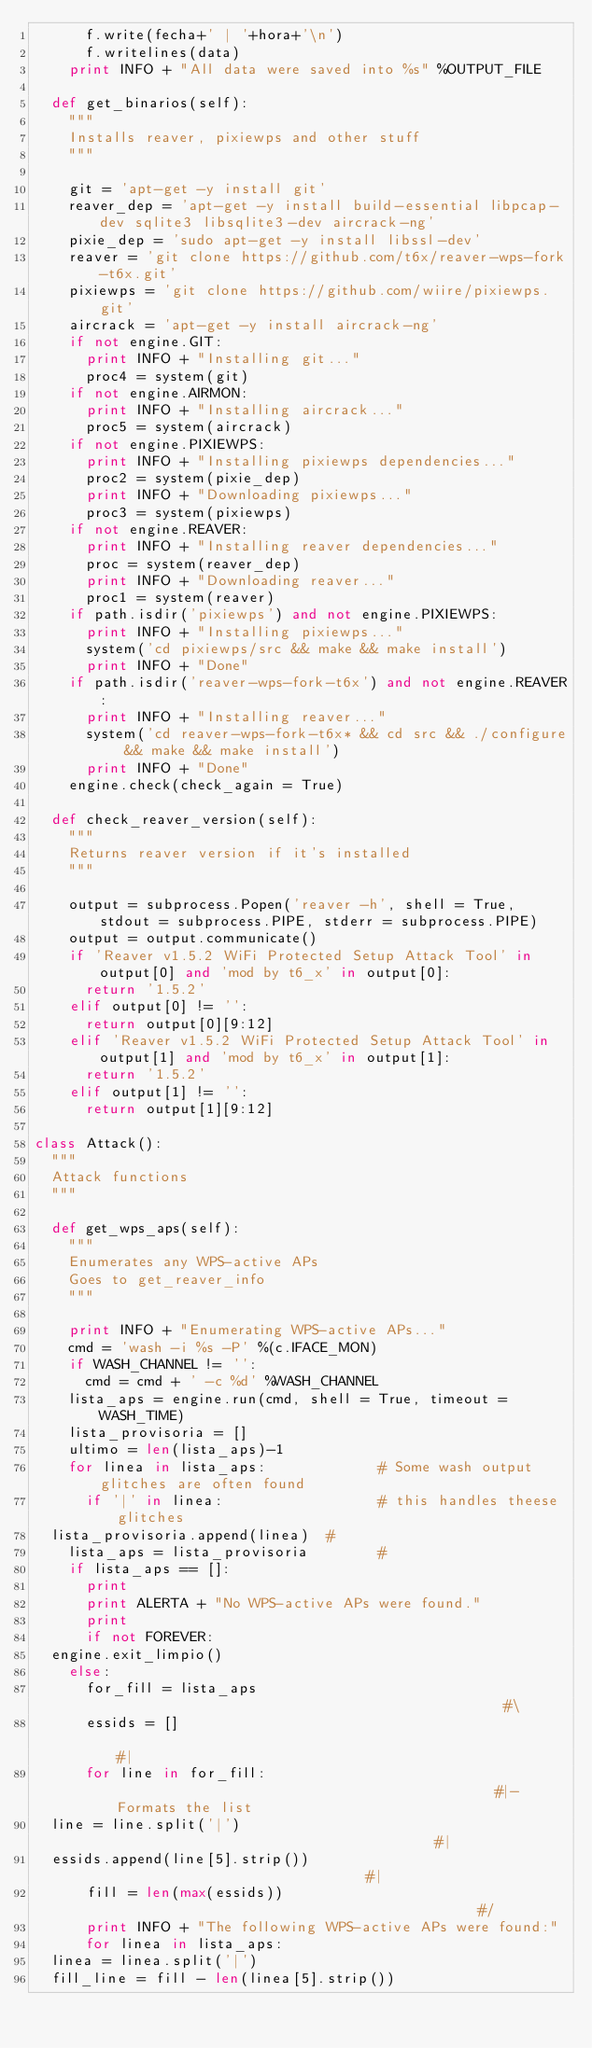Convert code to text. <code><loc_0><loc_0><loc_500><loc_500><_Python_>      f.write(fecha+' | '+hora+'\n')
      f.writelines(data)
    print INFO + "All data were saved into %s" %OUTPUT_FILE
    
  def get_binarios(self):
    """
    Installs reaver, pixiewps and other stuff
    """
    
    git = 'apt-get -y install git'
    reaver_dep = 'apt-get -y install build-essential libpcap-dev sqlite3 libsqlite3-dev aircrack-ng'
    pixie_dep = 'sudo apt-get -y install libssl-dev'
    reaver = 'git clone https://github.com/t6x/reaver-wps-fork-t6x.git'
    pixiewps = 'git clone https://github.com/wiire/pixiewps.git'
    aircrack = 'apt-get -y install aircrack-ng'
    if not engine.GIT:
      print INFO + "Installing git..."
      proc4 = system(git)
    if not engine.AIRMON:
      print INFO + "Installing aircrack..."
      proc5 = system(aircrack)
    if not engine.PIXIEWPS:
      print INFO + "Installing pixiewps dependencies..."
      proc2 = system(pixie_dep)
      print INFO + "Downloading pixiewps..."
      proc3 = system(pixiewps)    
    if not engine.REAVER:
      print INFO + "Installing reaver dependencies..."
      proc = system(reaver_dep)
      print INFO + "Downloading reaver..."
      proc1 = system(reaver)
    if path.isdir('pixiewps') and not engine.PIXIEWPS:
      print INFO + "Installing pixiewps..."
      system('cd pixiewps/src && make && make install')
      print INFO + "Done"
    if path.isdir('reaver-wps-fork-t6x') and not engine.REAVER:
      print INFO + "Installing reaver..."
      system('cd reaver-wps-fork-t6x* && cd src && ./configure && make && make install')
      print INFO + "Done"
    engine.check(check_again = True)

  def check_reaver_version(self):
    """
    Returns reaver version if it's installed
    """
    
    output = subprocess.Popen('reaver -h', shell = True, stdout = subprocess.PIPE, stderr = subprocess.PIPE)
    output = output.communicate()
    if 'Reaver v1.5.2 WiFi Protected Setup Attack Tool' in output[0] and 'mod by t6_x' in output[0]:
      return '1.5.2'
    elif output[0] != '':
      return output[0][9:12]
    elif 'Reaver v1.5.2 WiFi Protected Setup Attack Tool' in output[1] and 'mod by t6_x' in output[1]:
      return '1.5.2'
    elif output[1] != '':
      return output[1][9:12]

class Attack():
  """
  Attack functions
  """
  
  def get_wps_aps(self):
    """
    Enumerates any WPS-active APs
    Goes to get_reaver_info
    """

    print INFO + "Enumerating WPS-active APs..."
    cmd = 'wash -i %s -P' %(c.IFACE_MON)
    if WASH_CHANNEL != '':
      cmd = cmd + ' -c %d' %WASH_CHANNEL
    lista_aps = engine.run(cmd, shell = True, timeout = WASH_TIME)
    lista_provisoria = []
    ultimo = len(lista_aps)-1
    for linea in lista_aps:             # Some wash output glitches are often found
      if '|' in linea:                  # this handles theese glitches
	lista_provisoria.append(linea)  #
    lista_aps = lista_provisoria        #
    if lista_aps == []:
      print
      print ALERTA + "No WPS-active APs were found."
      print
      if not FOREVER:
	engine.exit_limpio()
    else:
      for_fill = lista_aps                                              #\
      essids = []                                                       #|
      for line in for_fill:                                             #|- Formats the list
	line = line.split('|')                                          #|
	essids.append(line[5].strip())                                  #|
      fill = len(max(essids))                                           #/
      print INFO + "The following WPS-active APs were found:"
      for linea in lista_aps:
	linea = linea.split('|')
	fill_line = fill - len(linea[5].strip())</code> 